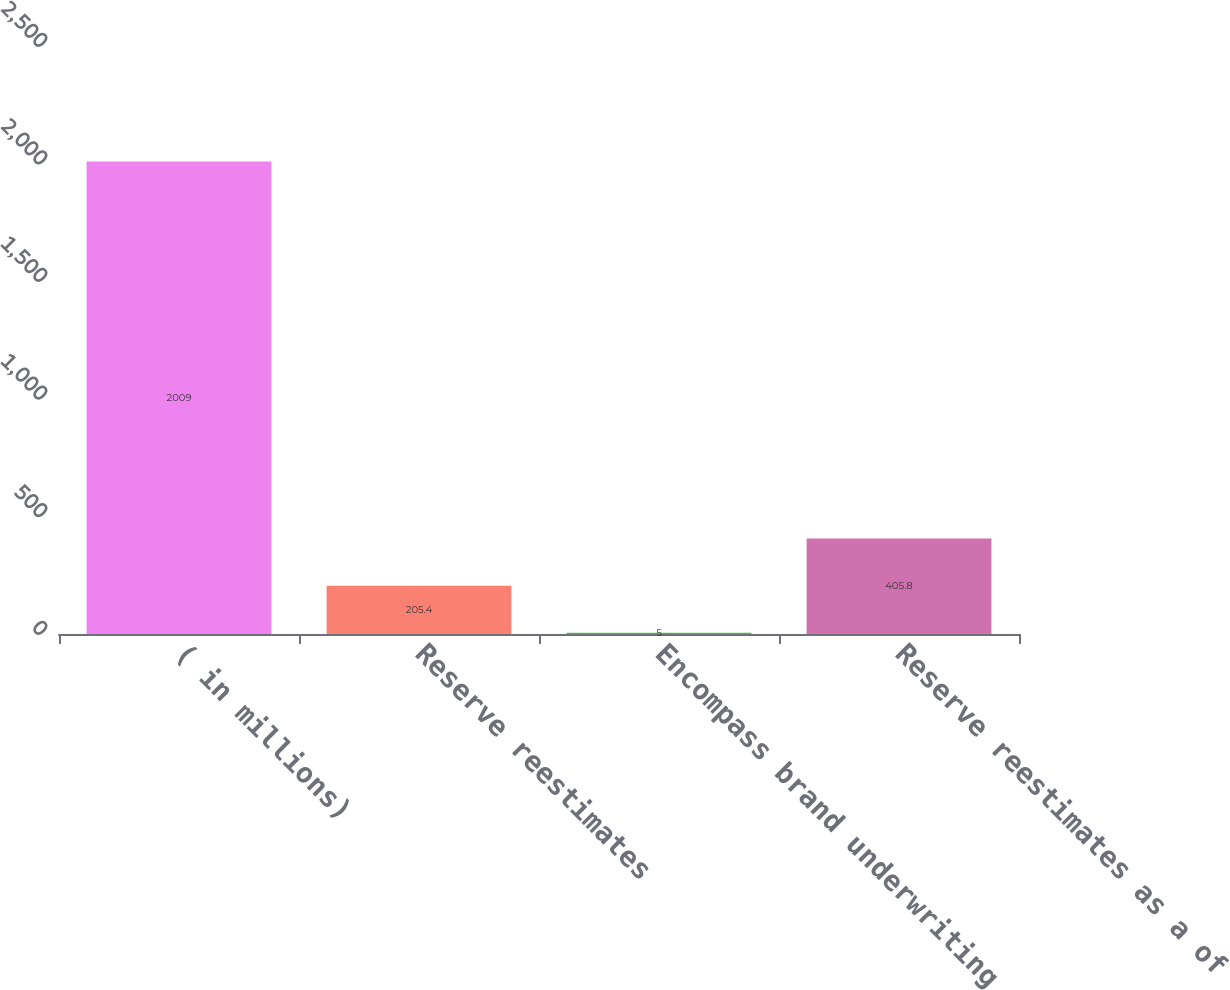Convert chart to OTSL. <chart><loc_0><loc_0><loc_500><loc_500><bar_chart><fcel>( in millions)<fcel>Reserve reestimates<fcel>Encompass brand underwriting<fcel>Reserve reestimates as a of<nl><fcel>2009<fcel>205.4<fcel>5<fcel>405.8<nl></chart> 